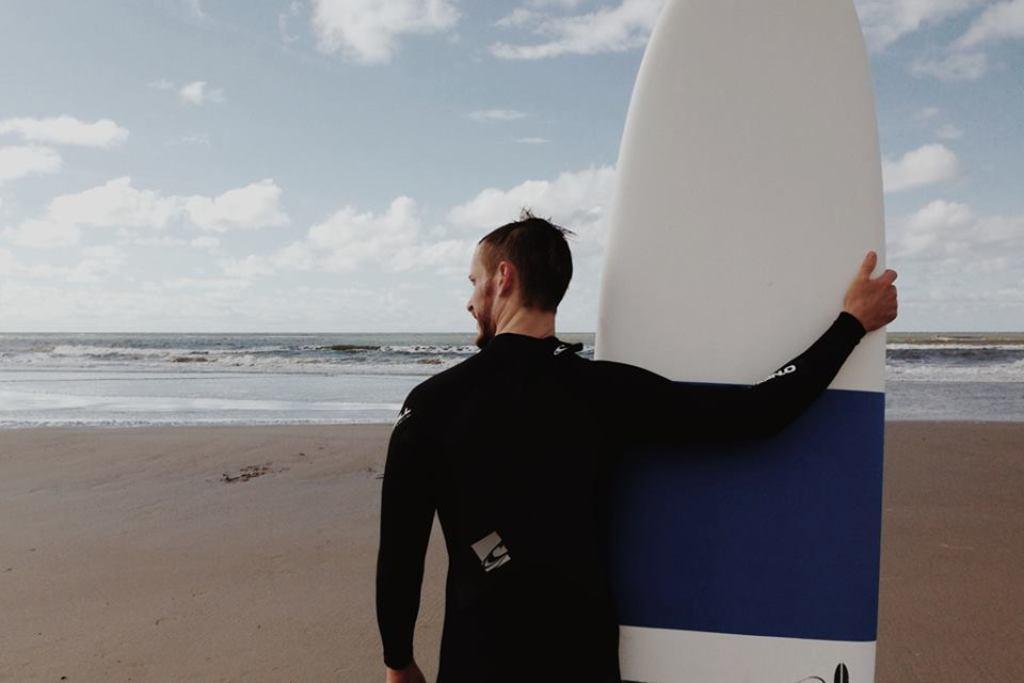Can you describe this image briefly? On the background we can see sky with clouds and it seems like a cloudy day. This is a beach. In Front of a beach we can see one man holding a surf board. 